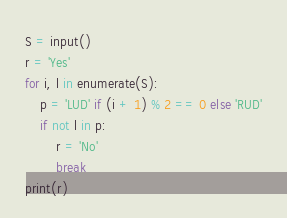<code> <loc_0><loc_0><loc_500><loc_500><_Python_>S = input()
r = 'Yes'
for i, l in enumerate(S):
    p = 'LUD' if (i + 1) % 2 == 0 else 'RUD'
    if not l in p:
        r = 'No'
        break
print(r)</code> 